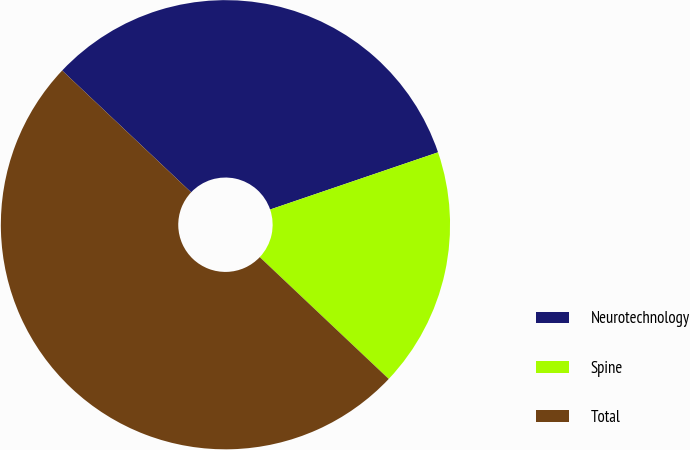Convert chart. <chart><loc_0><loc_0><loc_500><loc_500><pie_chart><fcel>Neurotechnology<fcel>Spine<fcel>Total<nl><fcel>32.73%<fcel>17.27%<fcel>50.0%<nl></chart> 